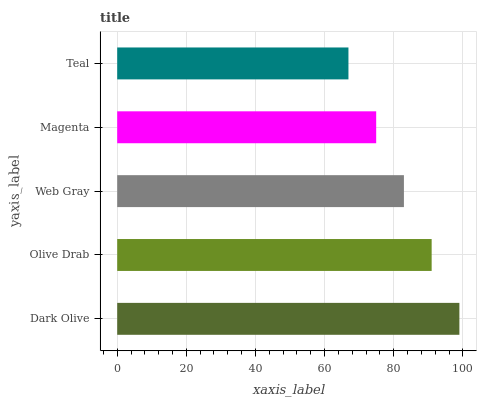Is Teal the minimum?
Answer yes or no. Yes. Is Dark Olive the maximum?
Answer yes or no. Yes. Is Olive Drab the minimum?
Answer yes or no. No. Is Olive Drab the maximum?
Answer yes or no. No. Is Dark Olive greater than Olive Drab?
Answer yes or no. Yes. Is Olive Drab less than Dark Olive?
Answer yes or no. Yes. Is Olive Drab greater than Dark Olive?
Answer yes or no. No. Is Dark Olive less than Olive Drab?
Answer yes or no. No. Is Web Gray the high median?
Answer yes or no. Yes. Is Web Gray the low median?
Answer yes or no. Yes. Is Olive Drab the high median?
Answer yes or no. No. Is Olive Drab the low median?
Answer yes or no. No. 